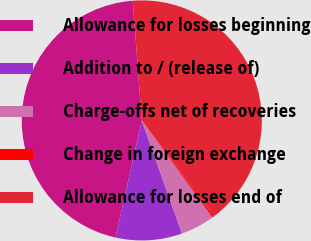Convert chart. <chart><loc_0><loc_0><loc_500><loc_500><pie_chart><fcel>Allowance for losses beginning<fcel>Addition to / (release of)<fcel>Charge-offs net of recoveries<fcel>Change in foreign exchange<fcel>Allowance for losses end of<nl><fcel>45.29%<fcel>8.94%<fcel>4.59%<fcel>0.24%<fcel>40.94%<nl></chart> 